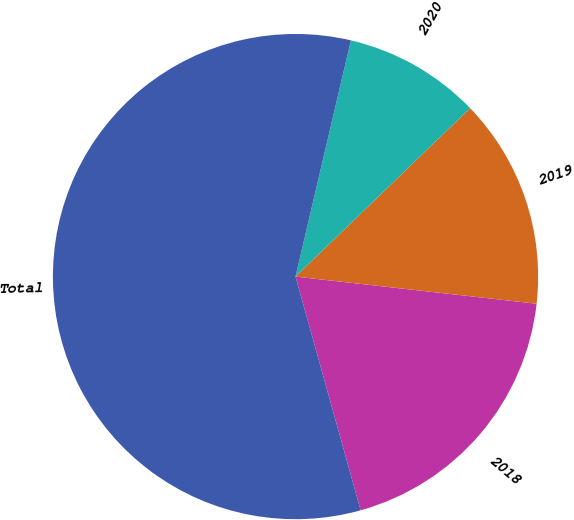Convert chart. <chart><loc_0><loc_0><loc_500><loc_500><pie_chart><fcel>2018<fcel>2019<fcel>2020<fcel>Total<nl><fcel>18.89%<fcel>14.0%<fcel>9.12%<fcel>57.99%<nl></chart> 